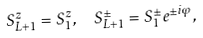Convert formula to latex. <formula><loc_0><loc_0><loc_500><loc_500>S ^ { z } _ { L + 1 } = S ^ { z } _ { 1 } , \ \ S ^ { \pm } _ { L + 1 } = S ^ { \pm } _ { 1 } e ^ { \pm i \varphi } ,</formula> 